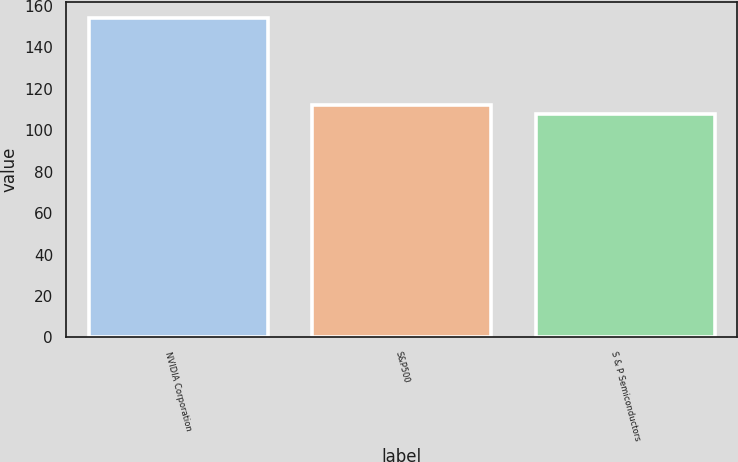Convert chart. <chart><loc_0><loc_0><loc_500><loc_500><bar_chart><fcel>NVIDIA Corporation<fcel>S&P500<fcel>S & P Semiconductors<nl><fcel>154.12<fcel>112.4<fcel>107.76<nl></chart> 